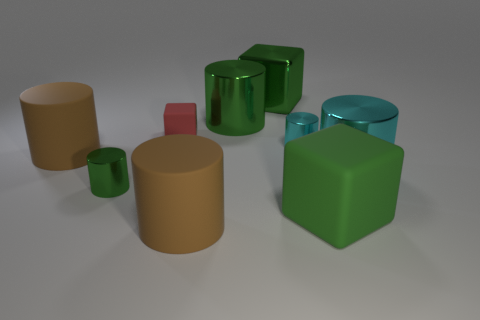Subtract all matte blocks. How many blocks are left? 1 Subtract all cylinders. How many objects are left? 3 Subtract all green cylinders. How many cylinders are left? 4 Subtract all cyan cylinders. How many yellow cubes are left? 0 Subtract all big matte cubes. Subtract all tiny red matte objects. How many objects are left? 7 Add 8 big brown rubber things. How many big brown rubber things are left? 10 Add 7 large rubber cubes. How many large rubber cubes exist? 8 Subtract 0 purple spheres. How many objects are left? 9 Subtract all yellow cylinders. Subtract all gray cubes. How many cylinders are left? 6 